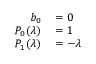<formula> <loc_0><loc_0><loc_500><loc_500>\begin{array} { r l } { b _ { 0 } } & = 0 } \\ { P _ { 0 } ( \lambda ) } & = 1 } \\ { P _ { 1 } ( \lambda ) } & = - \lambda } \end{array}</formula> 